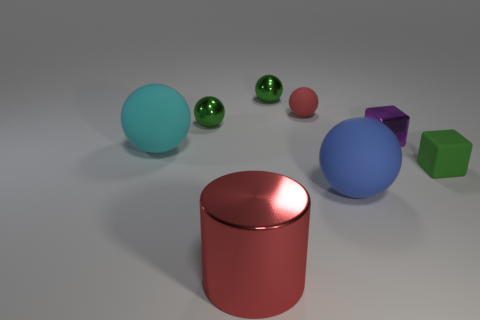Add 2 red metallic objects. How many objects exist? 10 Subtract all small green balls. How many balls are left? 3 Subtract all green cubes. How many cubes are left? 1 Subtract all green balls. Subtract all brown cylinders. How many balls are left? 3 Subtract all red cylinders. How many red blocks are left? 0 Subtract all red cylinders. Subtract all blue rubber spheres. How many objects are left? 6 Add 6 red matte spheres. How many red matte spheres are left? 7 Add 7 tiny metal cubes. How many tiny metal cubes exist? 8 Subtract 0 cyan cubes. How many objects are left? 8 Subtract all cylinders. How many objects are left? 7 